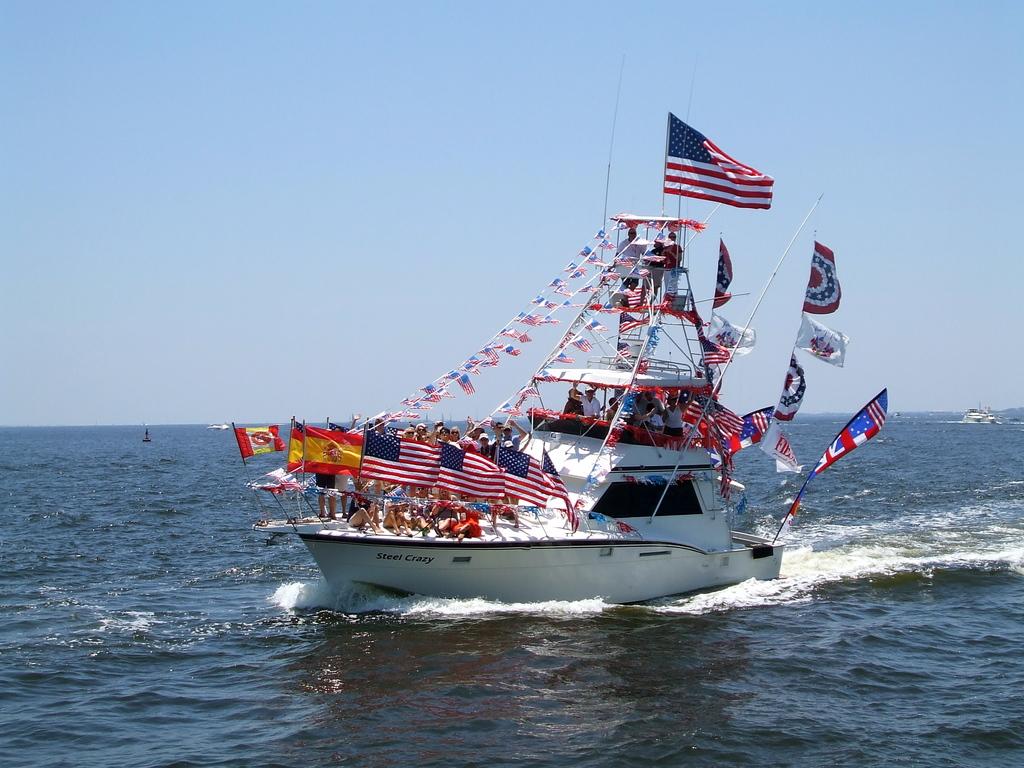What is written on the bow?
Your response must be concise. Steel crazy. The american ship?
Provide a short and direct response. Answering does not require reading text in the image. 